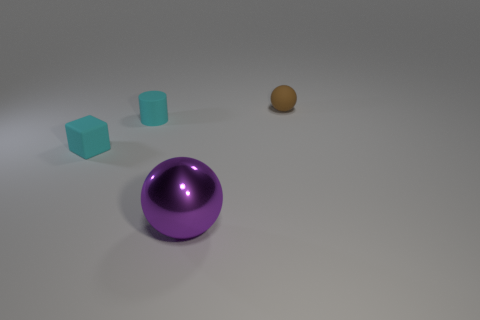Add 4 tiny purple cubes. How many objects exist? 8 Add 1 cyan rubber cylinders. How many cyan rubber cylinders are left? 2 Add 1 tiny cyan cubes. How many tiny cyan cubes exist? 2 Subtract 0 cyan balls. How many objects are left? 4 Subtract all large red matte balls. Subtract all small cyan rubber things. How many objects are left? 2 